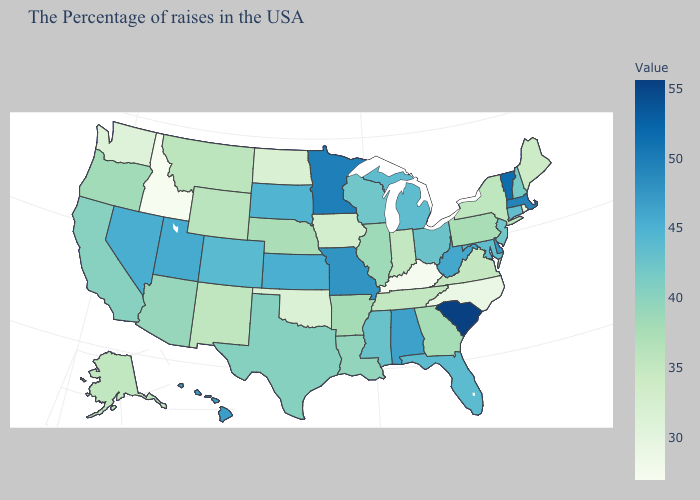Among the states that border New Hampshire , does Vermont have the highest value?
Answer briefly. Yes. Which states hav the highest value in the South?
Short answer required. South Carolina. Does Idaho have the lowest value in the USA?
Keep it brief. Yes. 